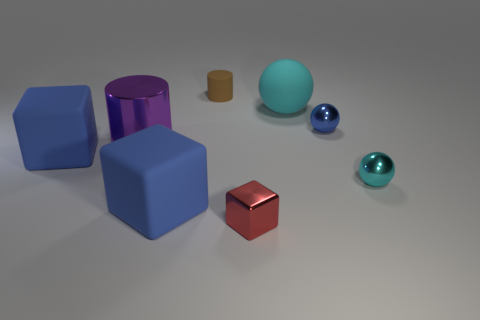Add 1 small cylinders. How many objects exist? 9 Subtract all cylinders. How many objects are left? 6 Add 8 tiny red blocks. How many tiny red blocks exist? 9 Subtract 0 blue cylinders. How many objects are left? 8 Subtract all blue cubes. Subtract all large purple metallic objects. How many objects are left? 5 Add 6 matte things. How many matte things are left? 10 